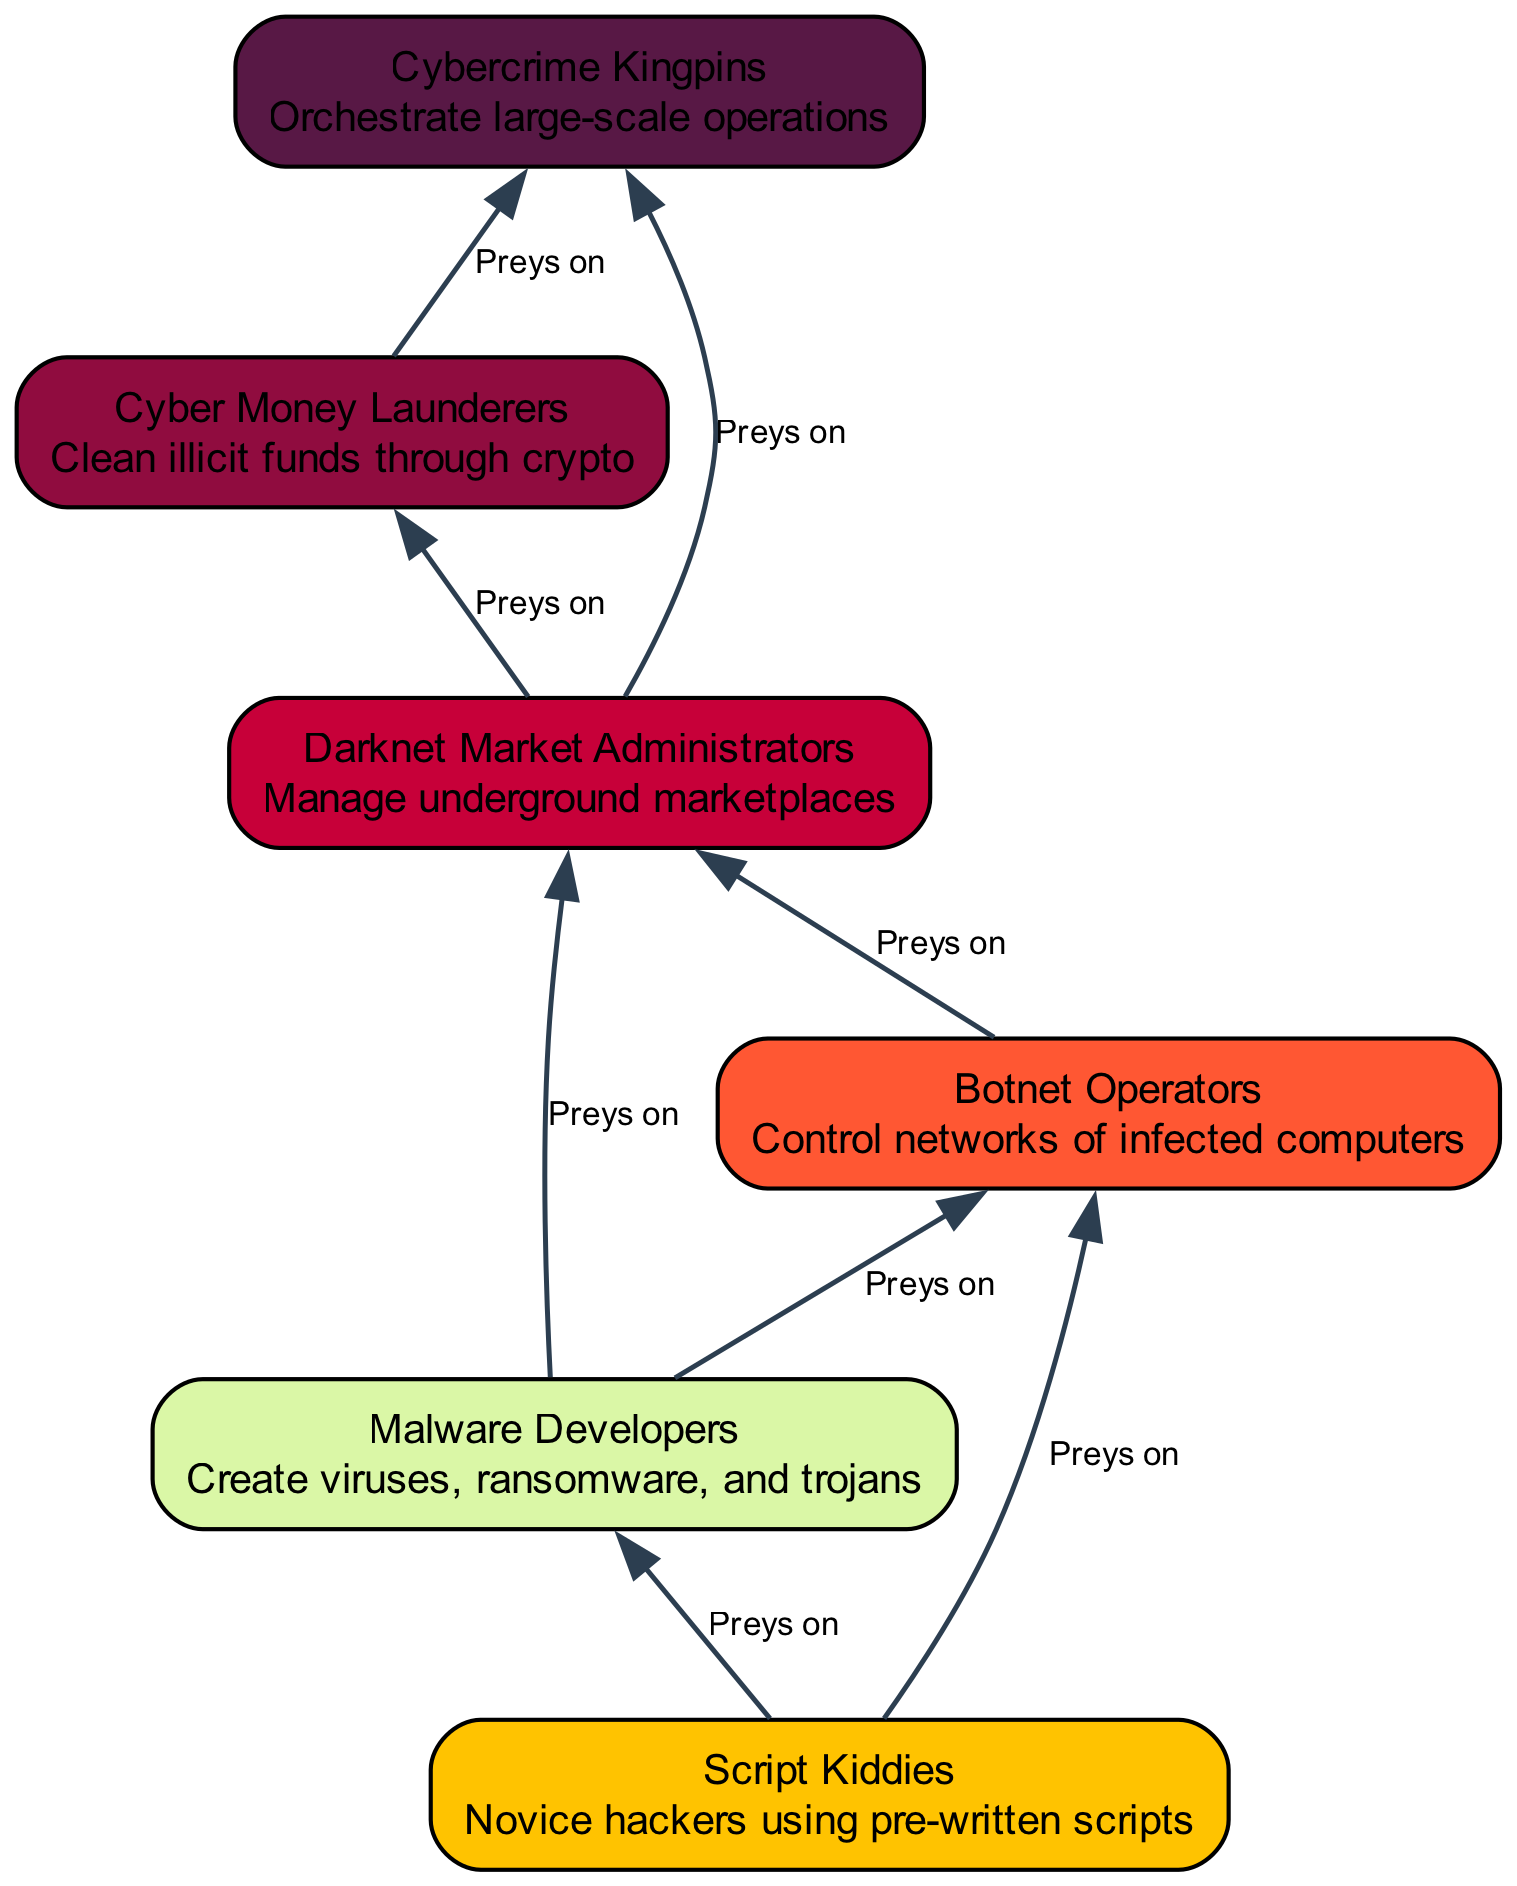What is the lowest level in the hierarchy? The lowest level in the hierarchy is "Script Kiddies," as it is the first element listed with no other elements preying on it.
Answer: Script Kiddies How many elements are there in the diagram? The diagram includes six elements, which are Script Kiddies, Malware Developers, Botnet Operators, Darknet Market Administrators, Cyber Money Launderers, and Cybercrime Kingpins.
Answer: six Which element preys on Malware Developers? The element that preys on Malware Developers is "Botnet Operators," as indicated by the direct relationship between these two elements in the diagram.
Answer: Botnet Operators Who is at the top of the cybercriminal ecosystem? The top of the cybercriminal ecosystem is "Cybercrime Kingpins," as they orchestrate the largest operations and are at the apex of the hierarchy.
Answer: Cybercrime Kingpins What role does "Cyber Money Launderers" play in the ecosystem? "Cyber Money Launderers" cleans illicit funds and are supported by "Darknet Market Administrators," indicating their crucial role in the financial aspect of cybercrime.
Answer: Cleans illicit funds How does the relationship flow from "Script Kiddies" to "Cybercrime Kingpins"? The flow starts from Script Kiddies to Malware Developers, which are then preyed upon by Botnet Operators. Next, Darknet Market Administrators manage assets from Malware Developers and Botnet Operators, followed by Cyber Money Launderers who clean funds obtained from Darknet Market Administrators, eventually leading to Cybercrime Kingpins who orchestrate the large-scale operations.
Answer: Through Malware Developers, Botnet Operators, Darknet Market Administrators, and Cyber Money Launderers Which element has the most direct connections to others? "Darknet Market Administrators" has the most direct connections, as it preys on both Malware Developers and Botnet Operators, impacting more facets of the cybercriminal ecosystem than any other element.
Answer: Darknet Market Administrators What is the relationship type between "Botnet Operators" and "Cyber Money Launderers"? There is no direct relationship between "Botnet Operators" and "Cyber Money Launderers" as indicated in the diagram; "Cyber Money Launderers" only prey on "Darknet Market Administrators" which indirectly connects them.
Answer: None How many different prey do the "Cybercrime Kingpins" have? "Cybercrime Kingpins" prey on two elements: "Darknet Market Administrators" and "Cyber Money Launderers."
Answer: two 